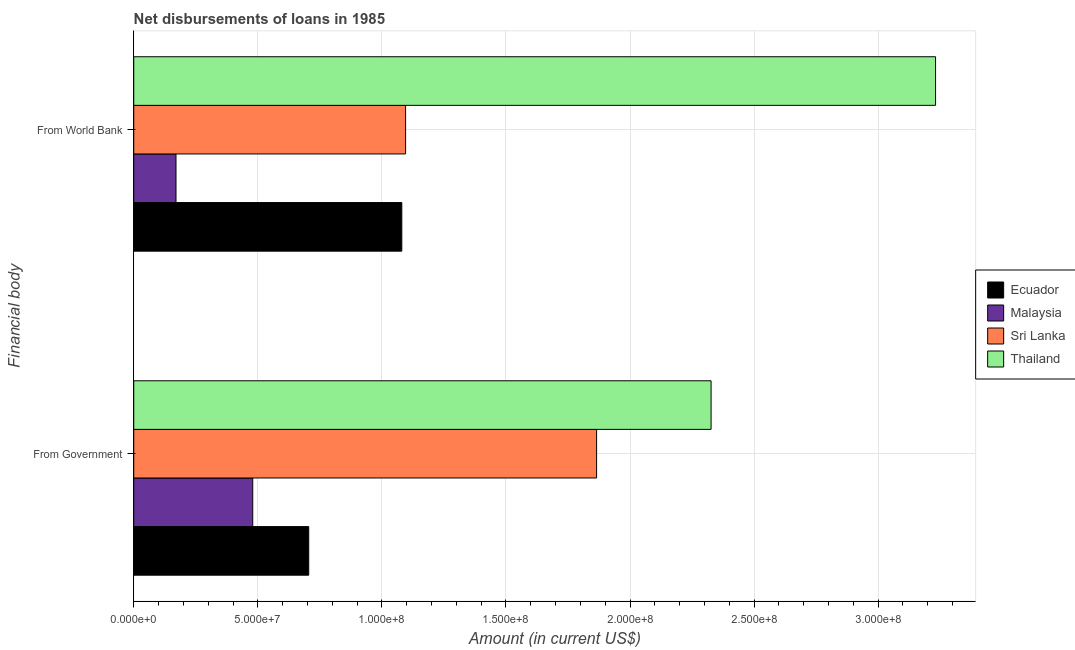Are the number of bars per tick equal to the number of legend labels?
Make the answer very short. Yes. How many bars are there on the 1st tick from the top?
Ensure brevity in your answer.  4. What is the label of the 1st group of bars from the top?
Provide a short and direct response. From World Bank. What is the net disbursements of loan from world bank in Ecuador?
Your answer should be compact. 1.08e+08. Across all countries, what is the maximum net disbursements of loan from world bank?
Your response must be concise. 3.23e+08. Across all countries, what is the minimum net disbursements of loan from government?
Offer a very short reply. 4.80e+07. In which country was the net disbursements of loan from government maximum?
Ensure brevity in your answer.  Thailand. In which country was the net disbursements of loan from government minimum?
Your answer should be compact. Malaysia. What is the total net disbursements of loan from government in the graph?
Provide a succinct answer. 5.38e+08. What is the difference between the net disbursements of loan from government in Thailand and that in Ecuador?
Offer a very short reply. 1.62e+08. What is the difference between the net disbursements of loan from world bank in Ecuador and the net disbursements of loan from government in Sri Lanka?
Offer a terse response. -7.85e+07. What is the average net disbursements of loan from government per country?
Your response must be concise. 1.34e+08. What is the difference between the net disbursements of loan from world bank and net disbursements of loan from government in Thailand?
Provide a succinct answer. 9.05e+07. What is the ratio of the net disbursements of loan from world bank in Thailand to that in Sri Lanka?
Keep it short and to the point. 2.95. In how many countries, is the net disbursements of loan from government greater than the average net disbursements of loan from government taken over all countries?
Keep it short and to the point. 2. What does the 1st bar from the top in From World Bank represents?
Your answer should be very brief. Thailand. What does the 4th bar from the bottom in From Government represents?
Ensure brevity in your answer.  Thailand. How many countries are there in the graph?
Provide a short and direct response. 4. What is the difference between two consecutive major ticks on the X-axis?
Offer a very short reply. 5.00e+07. Does the graph contain grids?
Ensure brevity in your answer.  Yes. How many legend labels are there?
Your answer should be compact. 4. What is the title of the graph?
Make the answer very short. Net disbursements of loans in 1985. Does "Eritrea" appear as one of the legend labels in the graph?
Keep it short and to the point. No. What is the label or title of the Y-axis?
Provide a short and direct response. Financial body. What is the Amount (in current US$) in Ecuador in From Government?
Ensure brevity in your answer.  7.05e+07. What is the Amount (in current US$) of Malaysia in From Government?
Your answer should be compact. 4.80e+07. What is the Amount (in current US$) in Sri Lanka in From Government?
Offer a very short reply. 1.87e+08. What is the Amount (in current US$) in Thailand in From Government?
Provide a succinct answer. 2.33e+08. What is the Amount (in current US$) of Ecuador in From World Bank?
Your answer should be very brief. 1.08e+08. What is the Amount (in current US$) in Malaysia in From World Bank?
Your answer should be very brief. 1.70e+07. What is the Amount (in current US$) of Sri Lanka in From World Bank?
Provide a succinct answer. 1.10e+08. What is the Amount (in current US$) of Thailand in From World Bank?
Offer a very short reply. 3.23e+08. Across all Financial body, what is the maximum Amount (in current US$) in Ecuador?
Offer a very short reply. 1.08e+08. Across all Financial body, what is the maximum Amount (in current US$) in Malaysia?
Your response must be concise. 4.80e+07. Across all Financial body, what is the maximum Amount (in current US$) in Sri Lanka?
Provide a succinct answer. 1.87e+08. Across all Financial body, what is the maximum Amount (in current US$) of Thailand?
Your answer should be compact. 3.23e+08. Across all Financial body, what is the minimum Amount (in current US$) in Ecuador?
Your answer should be compact. 7.05e+07. Across all Financial body, what is the minimum Amount (in current US$) of Malaysia?
Offer a very short reply. 1.70e+07. Across all Financial body, what is the minimum Amount (in current US$) in Sri Lanka?
Provide a short and direct response. 1.10e+08. Across all Financial body, what is the minimum Amount (in current US$) in Thailand?
Provide a succinct answer. 2.33e+08. What is the total Amount (in current US$) in Ecuador in the graph?
Offer a very short reply. 1.79e+08. What is the total Amount (in current US$) in Malaysia in the graph?
Keep it short and to the point. 6.50e+07. What is the total Amount (in current US$) in Sri Lanka in the graph?
Keep it short and to the point. 2.96e+08. What is the total Amount (in current US$) of Thailand in the graph?
Your answer should be compact. 5.56e+08. What is the difference between the Amount (in current US$) of Ecuador in From Government and that in From World Bank?
Your response must be concise. -3.75e+07. What is the difference between the Amount (in current US$) of Malaysia in From Government and that in From World Bank?
Your answer should be very brief. 3.09e+07. What is the difference between the Amount (in current US$) of Sri Lanka in From Government and that in From World Bank?
Your answer should be compact. 7.70e+07. What is the difference between the Amount (in current US$) of Thailand in From Government and that in From World Bank?
Your response must be concise. -9.05e+07. What is the difference between the Amount (in current US$) of Ecuador in From Government and the Amount (in current US$) of Malaysia in From World Bank?
Offer a very short reply. 5.35e+07. What is the difference between the Amount (in current US$) in Ecuador in From Government and the Amount (in current US$) in Sri Lanka in From World Bank?
Ensure brevity in your answer.  -3.90e+07. What is the difference between the Amount (in current US$) in Ecuador in From Government and the Amount (in current US$) in Thailand in From World Bank?
Provide a short and direct response. -2.53e+08. What is the difference between the Amount (in current US$) of Malaysia in From Government and the Amount (in current US$) of Sri Lanka in From World Bank?
Offer a very short reply. -6.16e+07. What is the difference between the Amount (in current US$) of Malaysia in From Government and the Amount (in current US$) of Thailand in From World Bank?
Offer a very short reply. -2.75e+08. What is the difference between the Amount (in current US$) in Sri Lanka in From Government and the Amount (in current US$) in Thailand in From World Bank?
Offer a terse response. -1.37e+08. What is the average Amount (in current US$) of Ecuador per Financial body?
Offer a very short reply. 8.93e+07. What is the average Amount (in current US$) in Malaysia per Financial body?
Your answer should be compact. 3.25e+07. What is the average Amount (in current US$) of Sri Lanka per Financial body?
Your answer should be compact. 1.48e+08. What is the average Amount (in current US$) of Thailand per Financial body?
Keep it short and to the point. 2.78e+08. What is the difference between the Amount (in current US$) in Ecuador and Amount (in current US$) in Malaysia in From Government?
Give a very brief answer. 2.26e+07. What is the difference between the Amount (in current US$) of Ecuador and Amount (in current US$) of Sri Lanka in From Government?
Provide a succinct answer. -1.16e+08. What is the difference between the Amount (in current US$) in Ecuador and Amount (in current US$) in Thailand in From Government?
Your answer should be very brief. -1.62e+08. What is the difference between the Amount (in current US$) in Malaysia and Amount (in current US$) in Sri Lanka in From Government?
Make the answer very short. -1.39e+08. What is the difference between the Amount (in current US$) in Malaysia and Amount (in current US$) in Thailand in From Government?
Your answer should be compact. -1.85e+08. What is the difference between the Amount (in current US$) of Sri Lanka and Amount (in current US$) of Thailand in From Government?
Make the answer very short. -4.61e+07. What is the difference between the Amount (in current US$) in Ecuador and Amount (in current US$) in Malaysia in From World Bank?
Make the answer very short. 9.10e+07. What is the difference between the Amount (in current US$) of Ecuador and Amount (in current US$) of Sri Lanka in From World Bank?
Give a very brief answer. -1.53e+06. What is the difference between the Amount (in current US$) in Ecuador and Amount (in current US$) in Thailand in From World Bank?
Your response must be concise. -2.15e+08. What is the difference between the Amount (in current US$) in Malaysia and Amount (in current US$) in Sri Lanka in From World Bank?
Offer a terse response. -9.25e+07. What is the difference between the Amount (in current US$) of Malaysia and Amount (in current US$) of Thailand in From World Bank?
Make the answer very short. -3.06e+08. What is the difference between the Amount (in current US$) of Sri Lanka and Amount (in current US$) of Thailand in From World Bank?
Your answer should be very brief. -2.14e+08. What is the ratio of the Amount (in current US$) of Ecuador in From Government to that in From World Bank?
Provide a short and direct response. 0.65. What is the ratio of the Amount (in current US$) in Malaysia in From Government to that in From World Bank?
Your answer should be very brief. 2.82. What is the ratio of the Amount (in current US$) of Sri Lanka in From Government to that in From World Bank?
Make the answer very short. 1.7. What is the ratio of the Amount (in current US$) in Thailand in From Government to that in From World Bank?
Your answer should be compact. 0.72. What is the difference between the highest and the second highest Amount (in current US$) in Ecuador?
Offer a terse response. 3.75e+07. What is the difference between the highest and the second highest Amount (in current US$) in Malaysia?
Offer a terse response. 3.09e+07. What is the difference between the highest and the second highest Amount (in current US$) of Sri Lanka?
Give a very brief answer. 7.70e+07. What is the difference between the highest and the second highest Amount (in current US$) in Thailand?
Your response must be concise. 9.05e+07. What is the difference between the highest and the lowest Amount (in current US$) in Ecuador?
Ensure brevity in your answer.  3.75e+07. What is the difference between the highest and the lowest Amount (in current US$) of Malaysia?
Provide a succinct answer. 3.09e+07. What is the difference between the highest and the lowest Amount (in current US$) in Sri Lanka?
Provide a succinct answer. 7.70e+07. What is the difference between the highest and the lowest Amount (in current US$) of Thailand?
Give a very brief answer. 9.05e+07. 